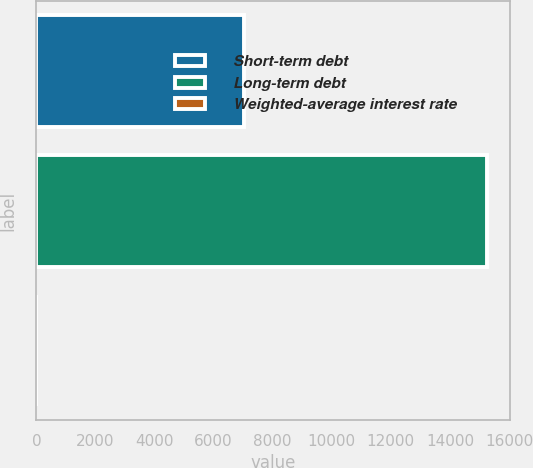Convert chart to OTSL. <chart><loc_0><loc_0><loc_500><loc_500><bar_chart><fcel>Short-term debt<fcel>Long-term debt<fcel>Weighted-average interest rate<nl><fcel>7046<fcel>15258<fcel>2<nl></chart> 